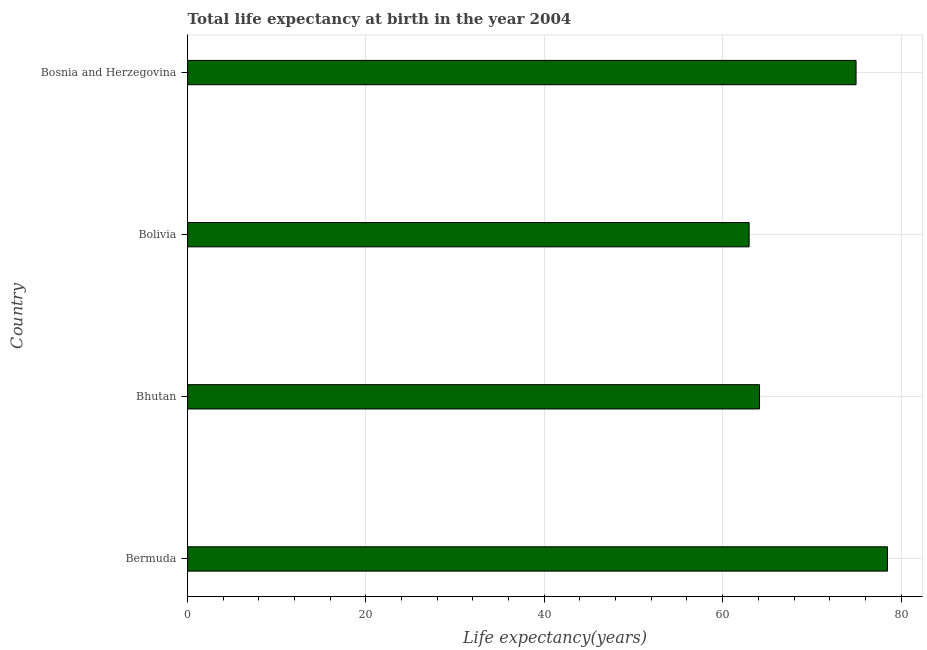Does the graph contain grids?
Your answer should be very brief. Yes. What is the title of the graph?
Your response must be concise. Total life expectancy at birth in the year 2004. What is the label or title of the X-axis?
Make the answer very short. Life expectancy(years). What is the label or title of the Y-axis?
Provide a short and direct response. Country. What is the life expectancy at birth in Bhutan?
Your answer should be very brief. 64.14. Across all countries, what is the maximum life expectancy at birth?
Offer a very short reply. 78.49. Across all countries, what is the minimum life expectancy at birth?
Make the answer very short. 62.97. In which country was the life expectancy at birth maximum?
Provide a short and direct response. Bermuda. What is the sum of the life expectancy at birth?
Provide a short and direct response. 280.55. What is the difference between the life expectancy at birth in Bermuda and Bosnia and Herzegovina?
Offer a very short reply. 3.53. What is the average life expectancy at birth per country?
Offer a very short reply. 70.14. What is the median life expectancy at birth?
Your answer should be compact. 69.55. What is the ratio of the life expectancy at birth in Bhutan to that in Bosnia and Herzegovina?
Provide a succinct answer. 0.86. Is the life expectancy at birth in Bermuda less than that in Bolivia?
Offer a terse response. No. Is the difference between the life expectancy at birth in Bermuda and Bosnia and Herzegovina greater than the difference between any two countries?
Offer a terse response. No. What is the difference between the highest and the second highest life expectancy at birth?
Provide a short and direct response. 3.53. Is the sum of the life expectancy at birth in Bermuda and Bhutan greater than the maximum life expectancy at birth across all countries?
Provide a succinct answer. Yes. What is the difference between the highest and the lowest life expectancy at birth?
Make the answer very short. 15.52. In how many countries, is the life expectancy at birth greater than the average life expectancy at birth taken over all countries?
Make the answer very short. 2. Are all the bars in the graph horizontal?
Your answer should be very brief. Yes. What is the Life expectancy(years) in Bermuda?
Your answer should be compact. 78.49. What is the Life expectancy(years) of Bhutan?
Provide a succinct answer. 64.14. What is the Life expectancy(years) of Bolivia?
Your answer should be compact. 62.97. What is the Life expectancy(years) in Bosnia and Herzegovina?
Keep it short and to the point. 74.96. What is the difference between the Life expectancy(years) in Bermuda and Bhutan?
Offer a very short reply. 14.35. What is the difference between the Life expectancy(years) in Bermuda and Bolivia?
Keep it short and to the point. 15.52. What is the difference between the Life expectancy(years) in Bermuda and Bosnia and Herzegovina?
Keep it short and to the point. 3.53. What is the difference between the Life expectancy(years) in Bhutan and Bolivia?
Your answer should be very brief. 1.17. What is the difference between the Life expectancy(years) in Bhutan and Bosnia and Herzegovina?
Keep it short and to the point. -10.82. What is the difference between the Life expectancy(years) in Bolivia and Bosnia and Herzegovina?
Make the answer very short. -11.99. What is the ratio of the Life expectancy(years) in Bermuda to that in Bhutan?
Give a very brief answer. 1.22. What is the ratio of the Life expectancy(years) in Bermuda to that in Bolivia?
Keep it short and to the point. 1.25. What is the ratio of the Life expectancy(years) in Bermuda to that in Bosnia and Herzegovina?
Offer a terse response. 1.05. What is the ratio of the Life expectancy(years) in Bhutan to that in Bosnia and Herzegovina?
Provide a succinct answer. 0.86. What is the ratio of the Life expectancy(years) in Bolivia to that in Bosnia and Herzegovina?
Your response must be concise. 0.84. 